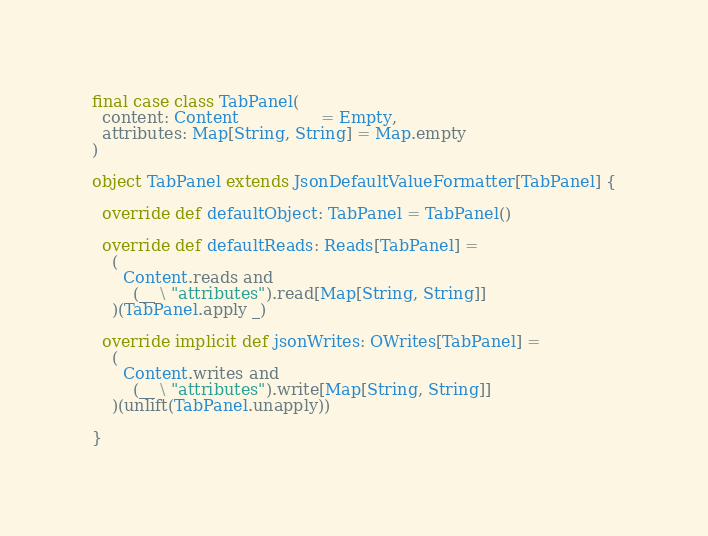Convert code to text. <code><loc_0><loc_0><loc_500><loc_500><_Scala_>final case class TabPanel(
  content: Content                = Empty,
  attributes: Map[String, String] = Map.empty
)

object TabPanel extends JsonDefaultValueFormatter[TabPanel] {

  override def defaultObject: TabPanel = TabPanel()

  override def defaultReads: Reads[TabPanel] =
    (
      Content.reads and
        (__ \ "attributes").read[Map[String, String]]
    )(TabPanel.apply _)

  override implicit def jsonWrites: OWrites[TabPanel] =
    (
      Content.writes and
        (__ \ "attributes").write[Map[String, String]]
    )(unlift(TabPanel.unapply))

}
</code> 